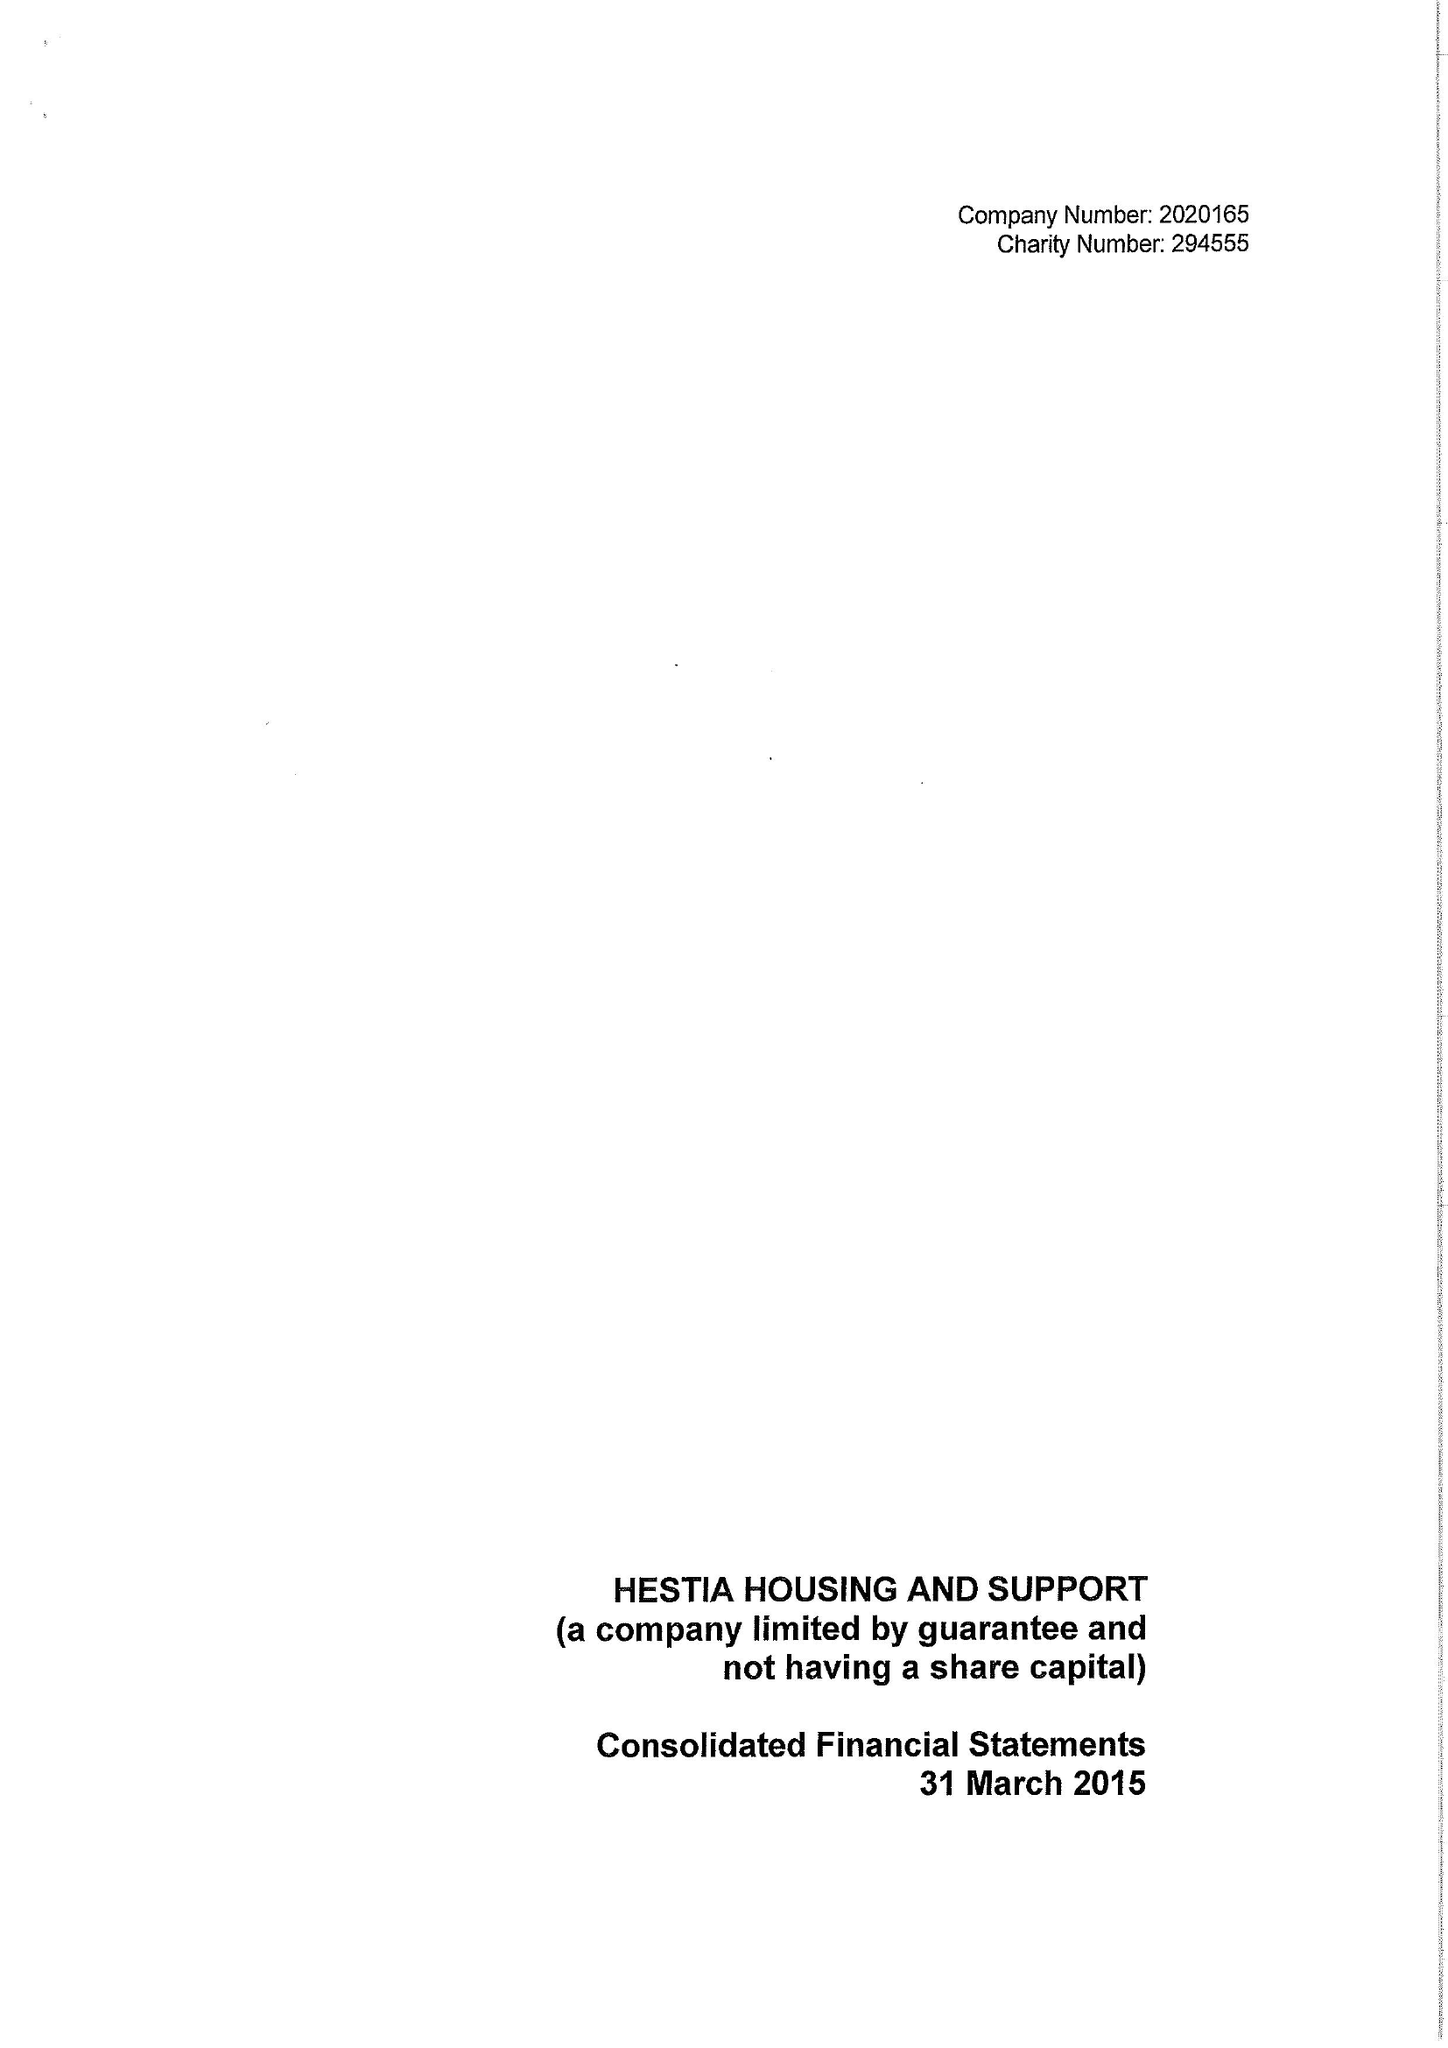What is the value for the address__postcode?
Answer the question using a single word or phrase. SE1 1LB 